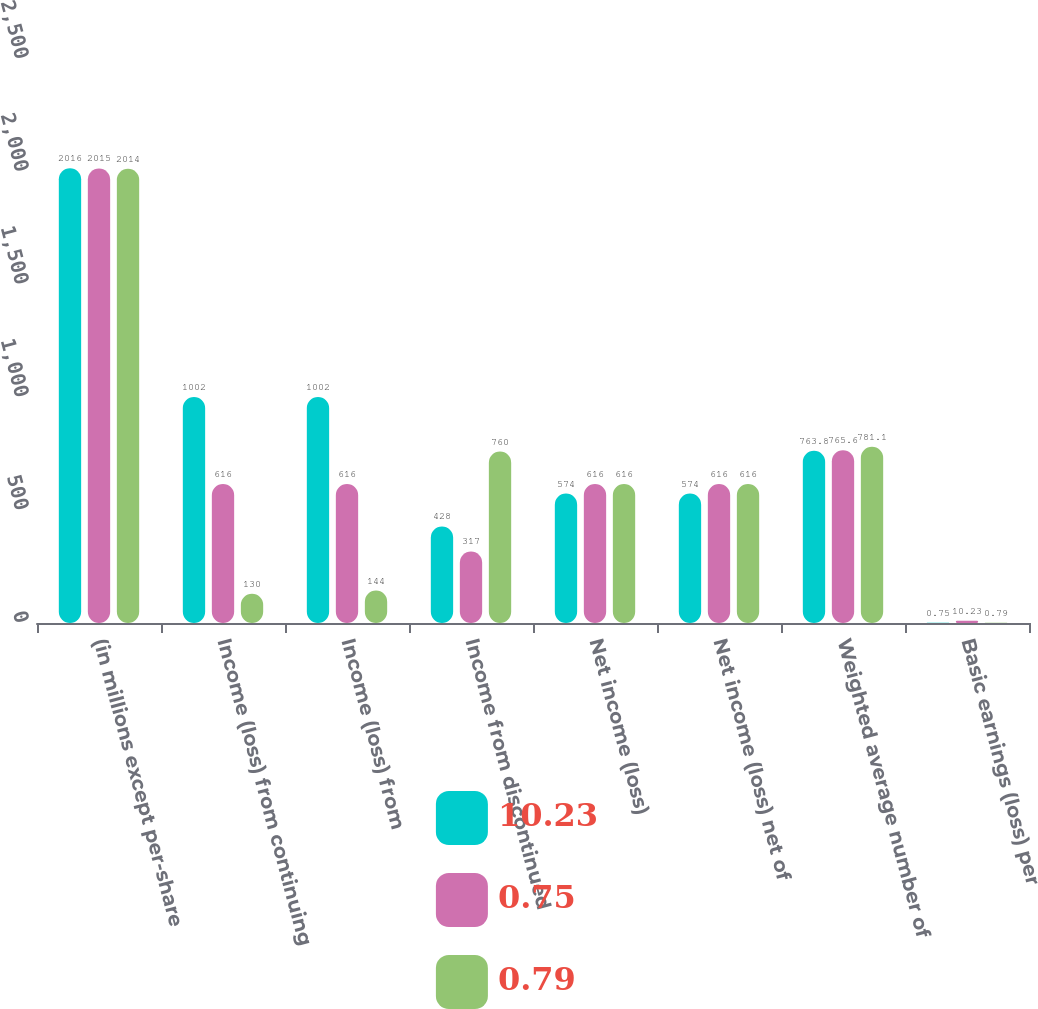<chart> <loc_0><loc_0><loc_500><loc_500><stacked_bar_chart><ecel><fcel>(in millions except per-share<fcel>Income (loss) from continuing<fcel>Income (loss) from<fcel>Income from discontinued<fcel>Net income (loss)<fcel>Net income (loss) net of<fcel>Weighted average number of<fcel>Basic earnings (loss) per<nl><fcel>10.23<fcel>2016<fcel>1002<fcel>1002<fcel>428<fcel>574<fcel>574<fcel>763.8<fcel>0.75<nl><fcel>0.75<fcel>2015<fcel>616<fcel>616<fcel>317<fcel>616<fcel>616<fcel>765.6<fcel>10.23<nl><fcel>0.79<fcel>2014<fcel>130<fcel>144<fcel>760<fcel>616<fcel>616<fcel>781.1<fcel>0.79<nl></chart> 